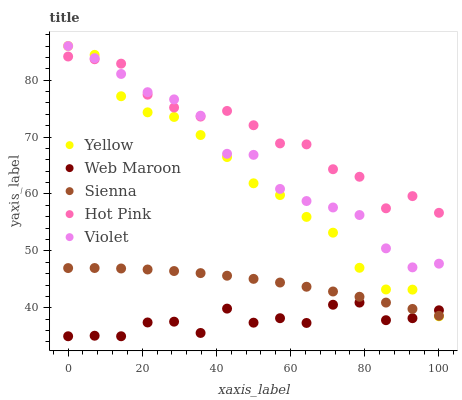Does Web Maroon have the minimum area under the curve?
Answer yes or no. Yes. Does Hot Pink have the maximum area under the curve?
Answer yes or no. Yes. Does Hot Pink have the minimum area under the curve?
Answer yes or no. No. Does Web Maroon have the maximum area under the curve?
Answer yes or no. No. Is Sienna the smoothest?
Answer yes or no. Yes. Is Hot Pink the roughest?
Answer yes or no. Yes. Is Web Maroon the smoothest?
Answer yes or no. No. Is Web Maroon the roughest?
Answer yes or no. No. Does Web Maroon have the lowest value?
Answer yes or no. Yes. Does Hot Pink have the lowest value?
Answer yes or no. No. Does Violet have the highest value?
Answer yes or no. Yes. Does Hot Pink have the highest value?
Answer yes or no. No. Is Web Maroon less than Violet?
Answer yes or no. Yes. Is Violet greater than Sienna?
Answer yes or no. Yes. Does Yellow intersect Sienna?
Answer yes or no. Yes. Is Yellow less than Sienna?
Answer yes or no. No. Is Yellow greater than Sienna?
Answer yes or no. No. Does Web Maroon intersect Violet?
Answer yes or no. No. 